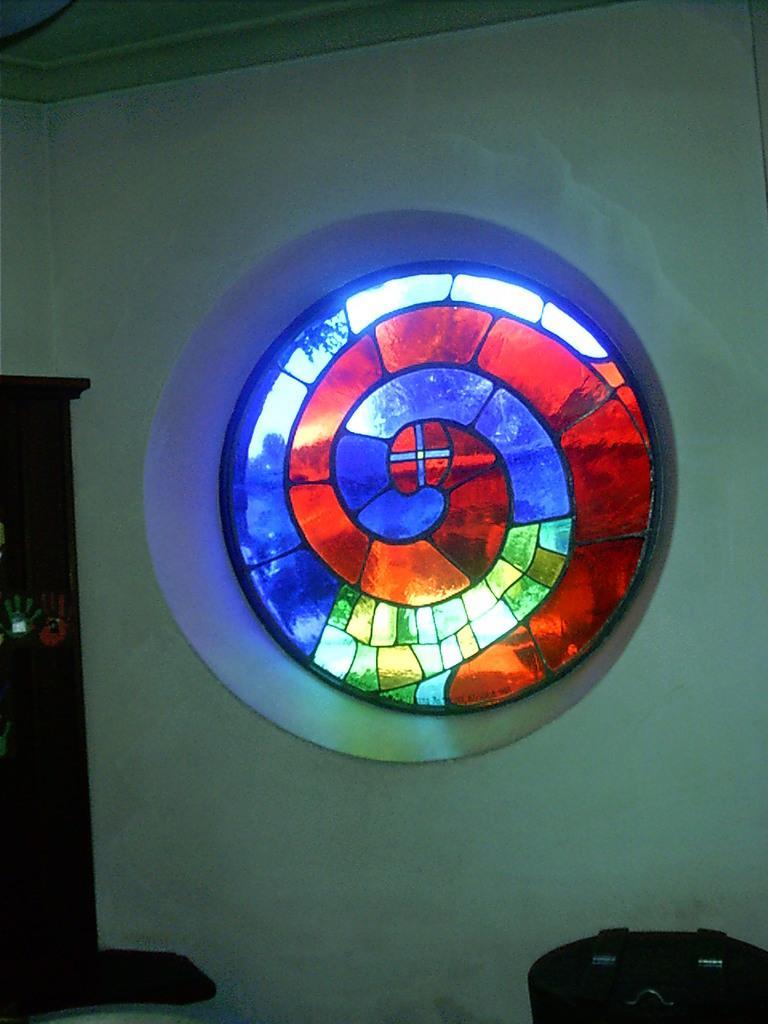Could you give a brief overview of what you see in this image? In this image I can see a stained glass to the wall. In the bottom right-hand corner there is a table. On the left side there is a cupboard. 